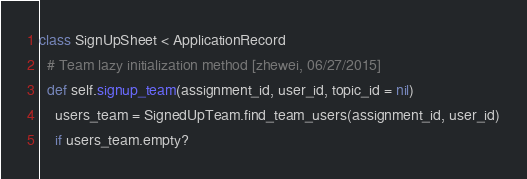Convert code to text. <code><loc_0><loc_0><loc_500><loc_500><_Ruby_>class SignUpSheet < ApplicationRecord
  # Team lazy initialization method [zhewei, 06/27/2015]
  def self.signup_team(assignment_id, user_id, topic_id = nil)
    users_team = SignedUpTeam.find_team_users(assignment_id, user_id)
    if users_team.empty?</code> 